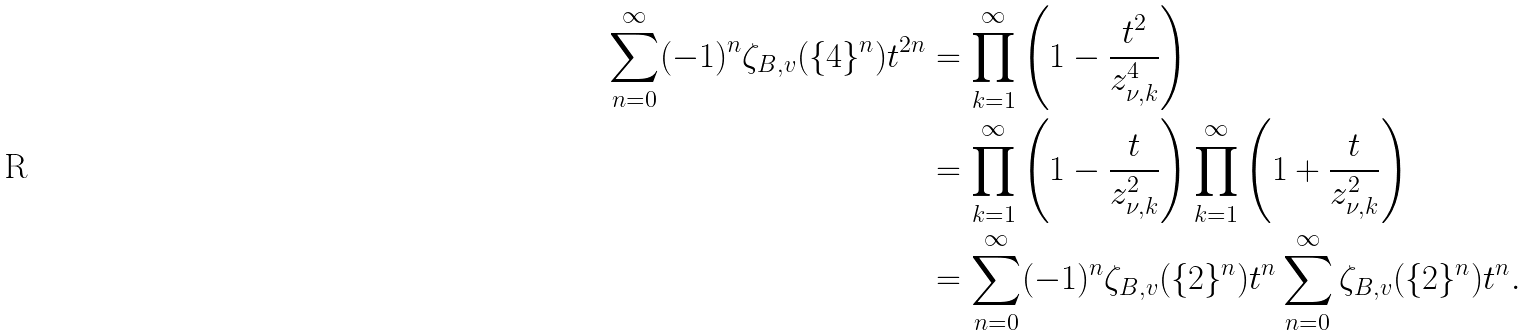Convert formula to latex. <formula><loc_0><loc_0><loc_500><loc_500>\sum _ { n = 0 } ^ { \infty } ( - 1 ) ^ { n } \zeta _ { B , v } ( \{ 4 \} ^ { n } ) t ^ { 2 n } & = \prod _ { k = 1 } ^ { \infty } \left ( 1 - \frac { t ^ { 2 } } { z _ { \nu , k } ^ { 4 } } \right ) \\ & = \prod _ { k = 1 } ^ { \infty } \left ( 1 - \frac { t } { z _ { \nu , k } ^ { 2 } } \right ) \prod _ { k = 1 } ^ { \infty } \left ( 1 + \frac { t } { z _ { \nu , k } ^ { 2 } } \right ) \\ & = \sum _ { n = 0 } ^ { \infty } ( - 1 ) ^ { n } \zeta _ { B , v } ( \{ 2 \} ^ { n } ) t ^ { n } \sum _ { n = 0 } ^ { \infty } \zeta _ { B , v } ( \{ 2 \} ^ { n } ) t ^ { n } .</formula> 